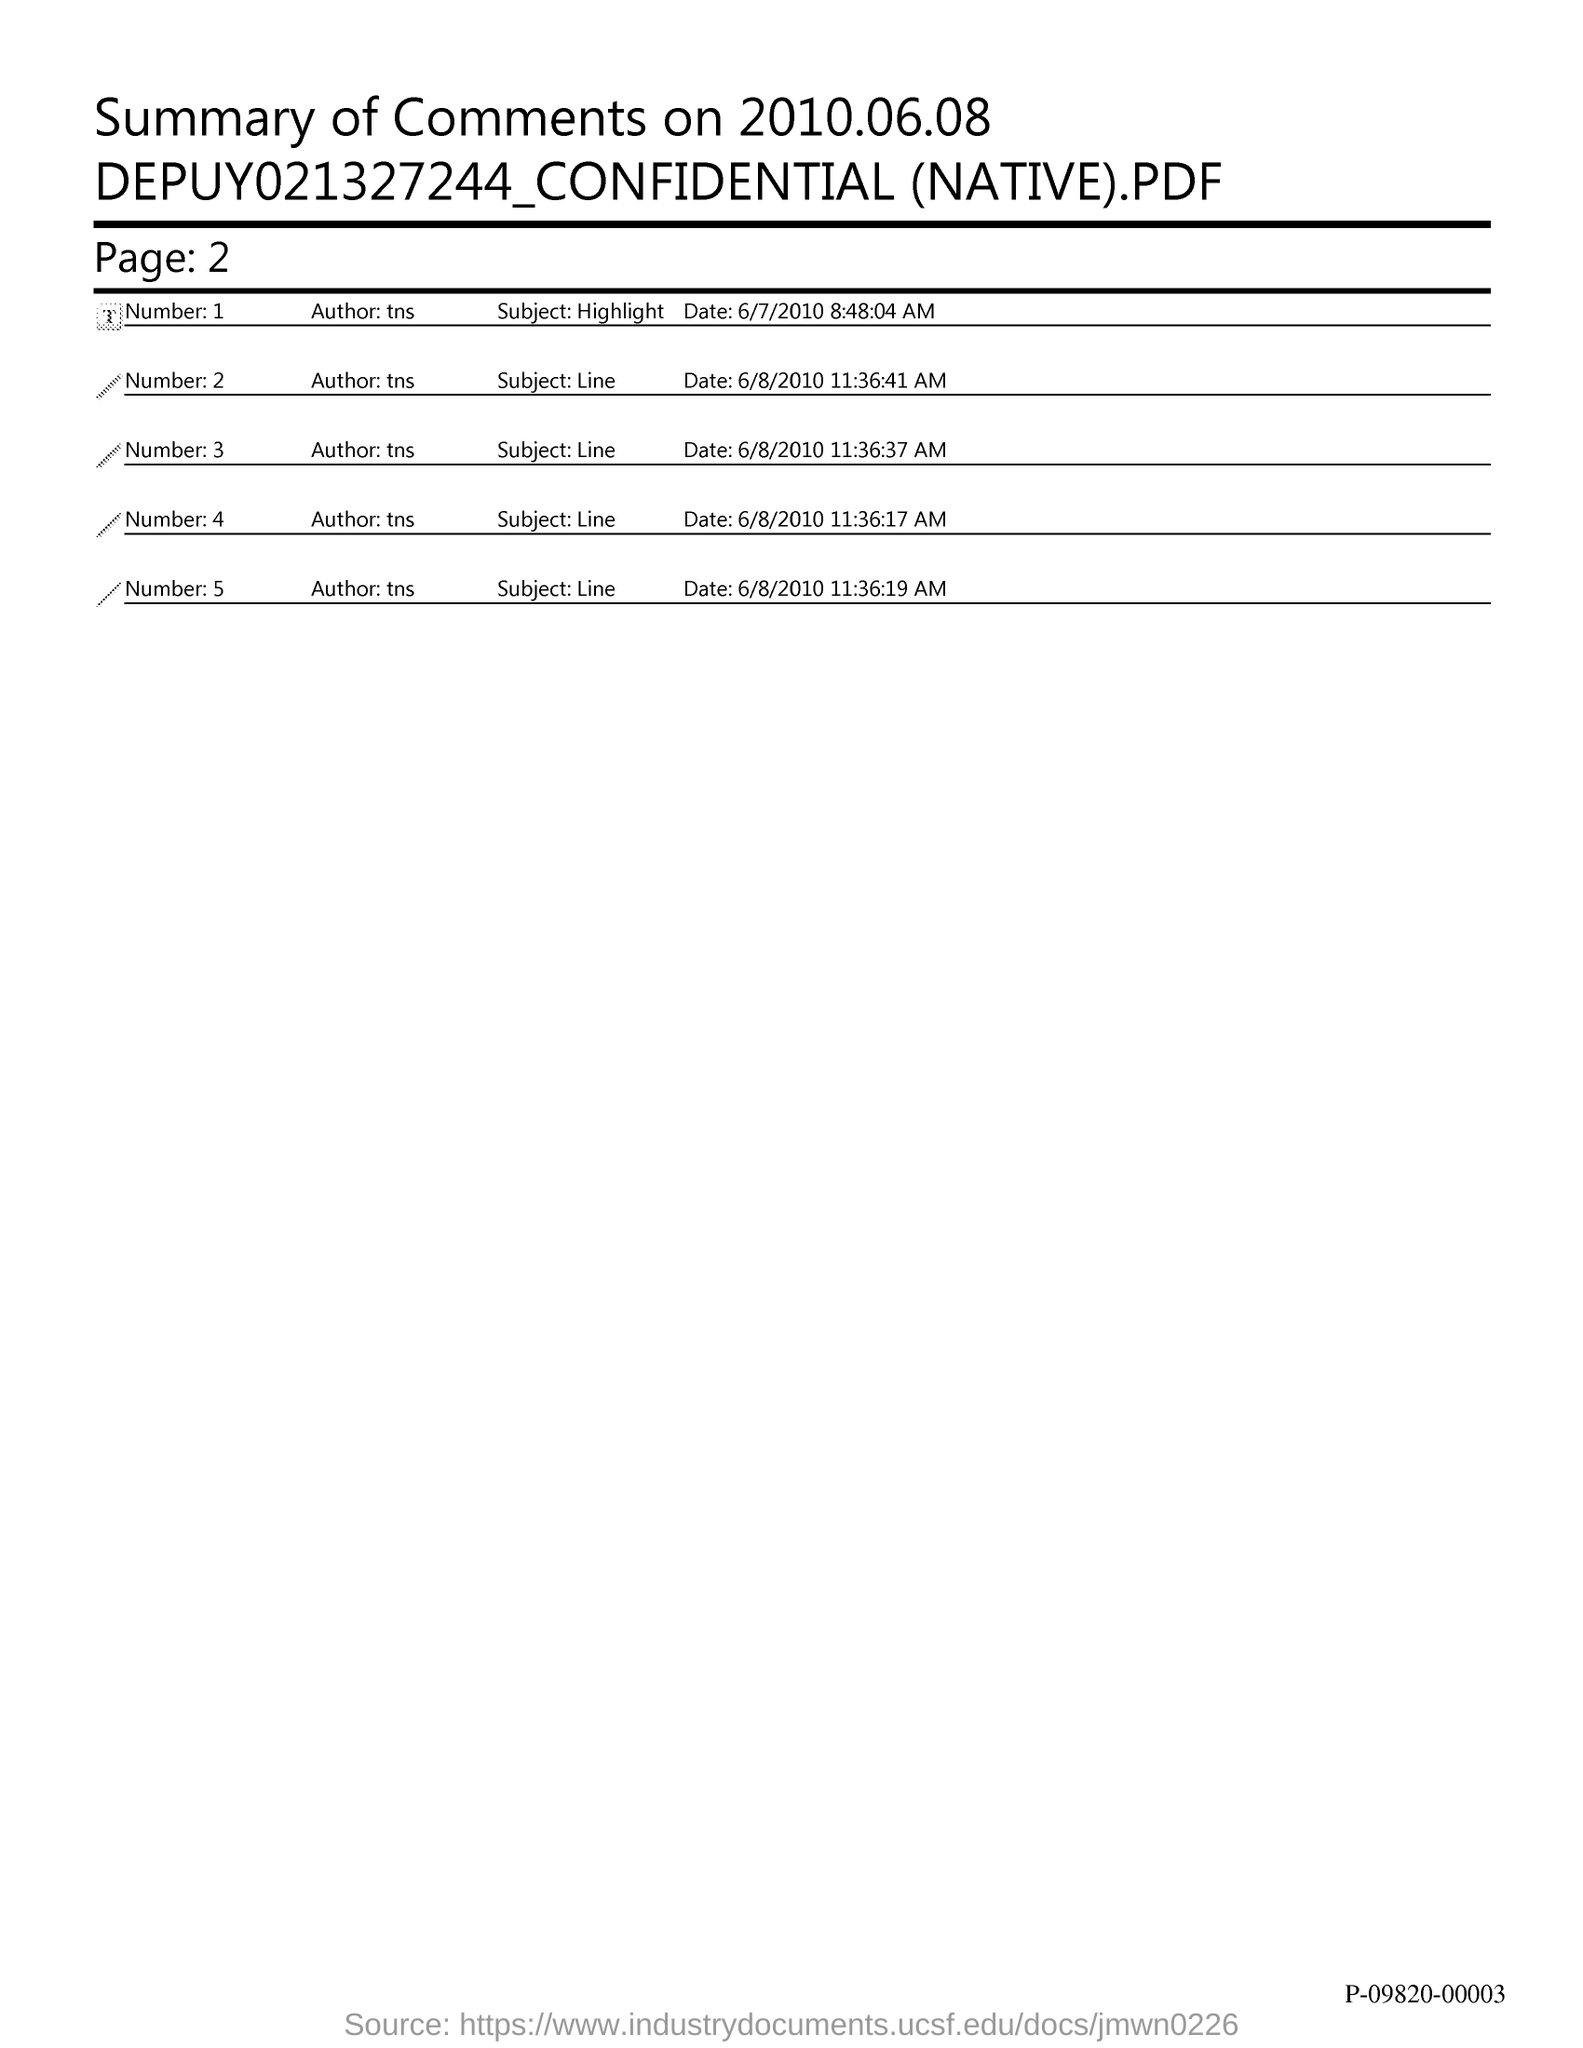Draw attention to some important aspects in this diagram. The page number is 2, as declared. On June 8th, 2010, comments were made. 